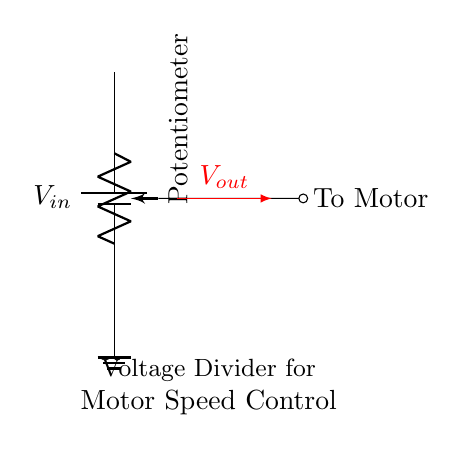What is the input voltage of this circuit? The input voltage is represented by V_in, indicating the voltage supplied to the circuit before the voltage divider is activated.
Answer: V_in What type of component is used to vary voltage? The potentiometer serves as the component that varies voltage output by adjusting its wiper position, impacting the voltage divider's output.
Answer: Potentiometer Where is the output voltage taken from? The output voltage V_out is taken from the wiper of the potentiometer, connecting to the motor. This shows how the varying resistance changes the output voltage to control the motor.
Answer: Potentiometer wiper How does this circuit control motor speed? By adjusting the resistance of the potentiometer, it changes the voltage supplied to the motor. A lower resistance allows for a higher voltage and thereby a faster motor speed, while a higher resistance results in a lower voltage and slower speed.
Answer: By varying voltage What is the purpose of the ground connection? The ground connection provides a reference point for the voltage in the circuit, ensuring the circuit is complete and allowing the current to return after passing through the motor and potentiometer.
Answer: Reference point What happens if the potentiometer is set to maximum resistance? When the potentiometer is at maximum resistance, the output voltage V_out drops to zero, effectively stopping the motor, as no sufficient voltage will reach it to operate.
Answer: Motor stops 